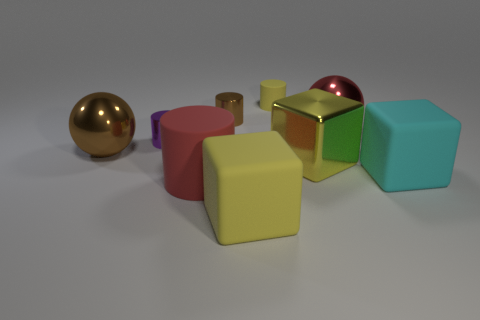There is a big metal object that is in front of the small purple metallic object and to the right of the big brown metal object; what is its shape?
Give a very brief answer. Cube. There is a rubber object that is behind the big shiny ball that is to the right of the yellow object that is in front of the big metal cube; what shape is it?
Provide a succinct answer. Cylinder. What is the material of the yellow thing that is to the left of the metal cube and in front of the large brown ball?
Your response must be concise. Rubber. What number of yellow objects have the same size as the cyan matte cube?
Keep it short and to the point. 2. How many metallic things are either tiny cyan spheres or yellow blocks?
Offer a very short reply. 1. What material is the red sphere?
Your response must be concise. Metal. What number of red objects are in front of the large brown ball?
Provide a succinct answer. 1. Is the red cylinder that is in front of the red metallic sphere made of the same material as the yellow cylinder?
Offer a terse response. Yes. How many big objects have the same shape as the tiny brown metal object?
Your answer should be compact. 1. How many large objects are either purple cylinders or green matte spheres?
Your response must be concise. 0. 